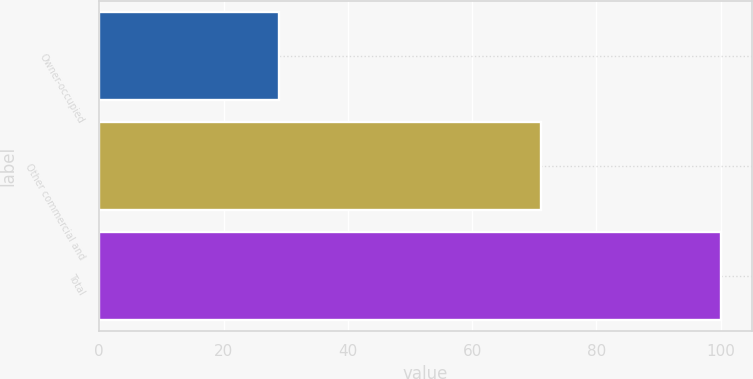Convert chart to OTSL. <chart><loc_0><loc_0><loc_500><loc_500><bar_chart><fcel>Owner-occupied<fcel>Other commercial and<fcel>Total<nl><fcel>29<fcel>71<fcel>100<nl></chart> 